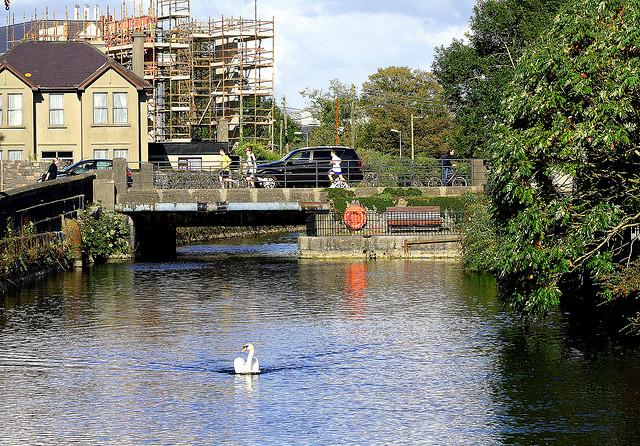Why is he running on the bridge?

Choices:
A) stay dry
B) less windy
C) being followed
D) shorter run stay dry 